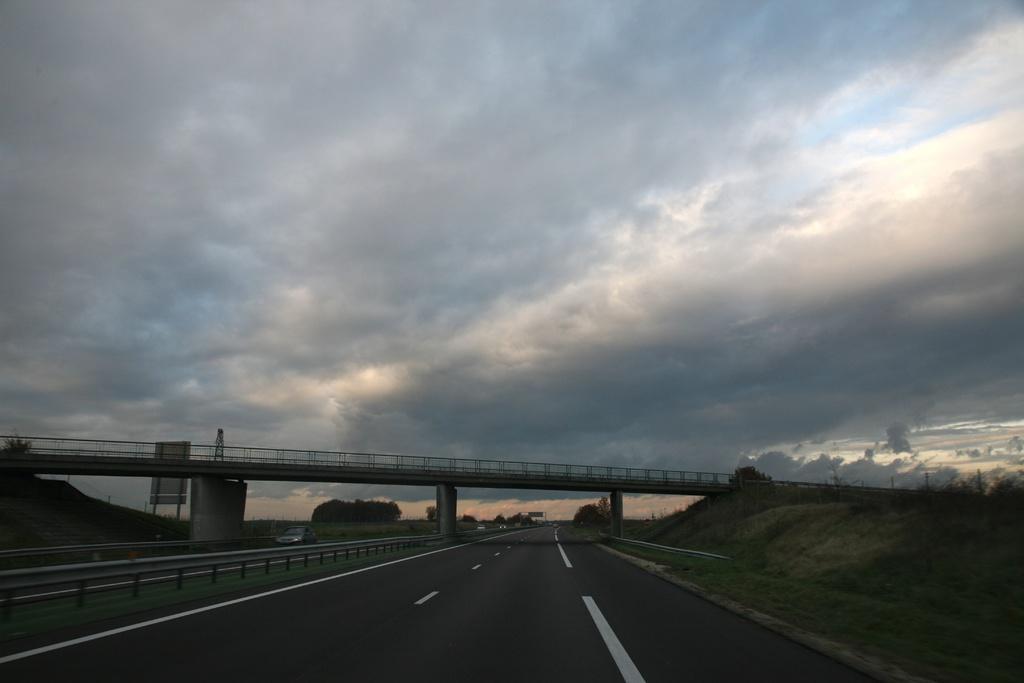Can you describe this image briefly? In the center of the image there is a flyover. At the bottom there is a road. In the background we can see trees, sky and clouds. 